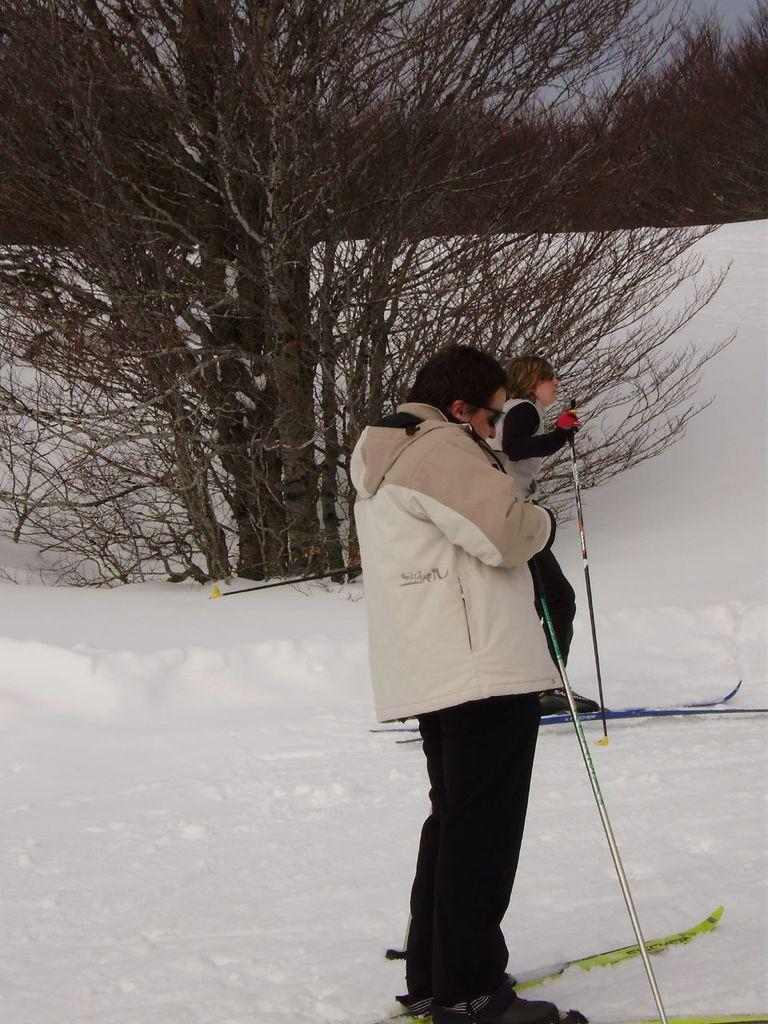How many people are in the image? There are two people in the image. What are the people doing in the image? The people are on skiboards. What can be seen in the background of the image? There is a tree in the background of the image. What is the condition of the ground in the image? The ground is covered in snow. What type of bee can be seen buzzing around the mailbox in the image? There is no bee or mailbox present in the image. What disease might the people in the image be trying to avoid by being on skiboards? The image does not provide any information about diseases or health concerns related to the people in the image, so it is not possible to determine what disease they might be trying to avoid. 